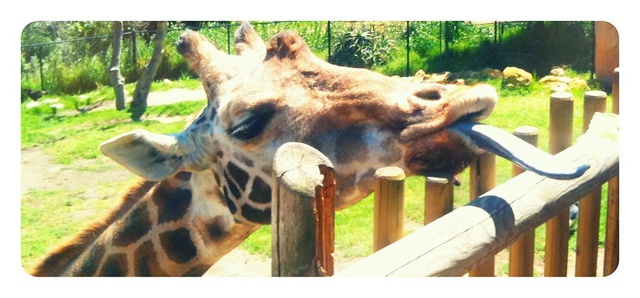Describe the objects in this image and their specific colors. I can see a giraffe in white, gray, beige, and black tones in this image. 